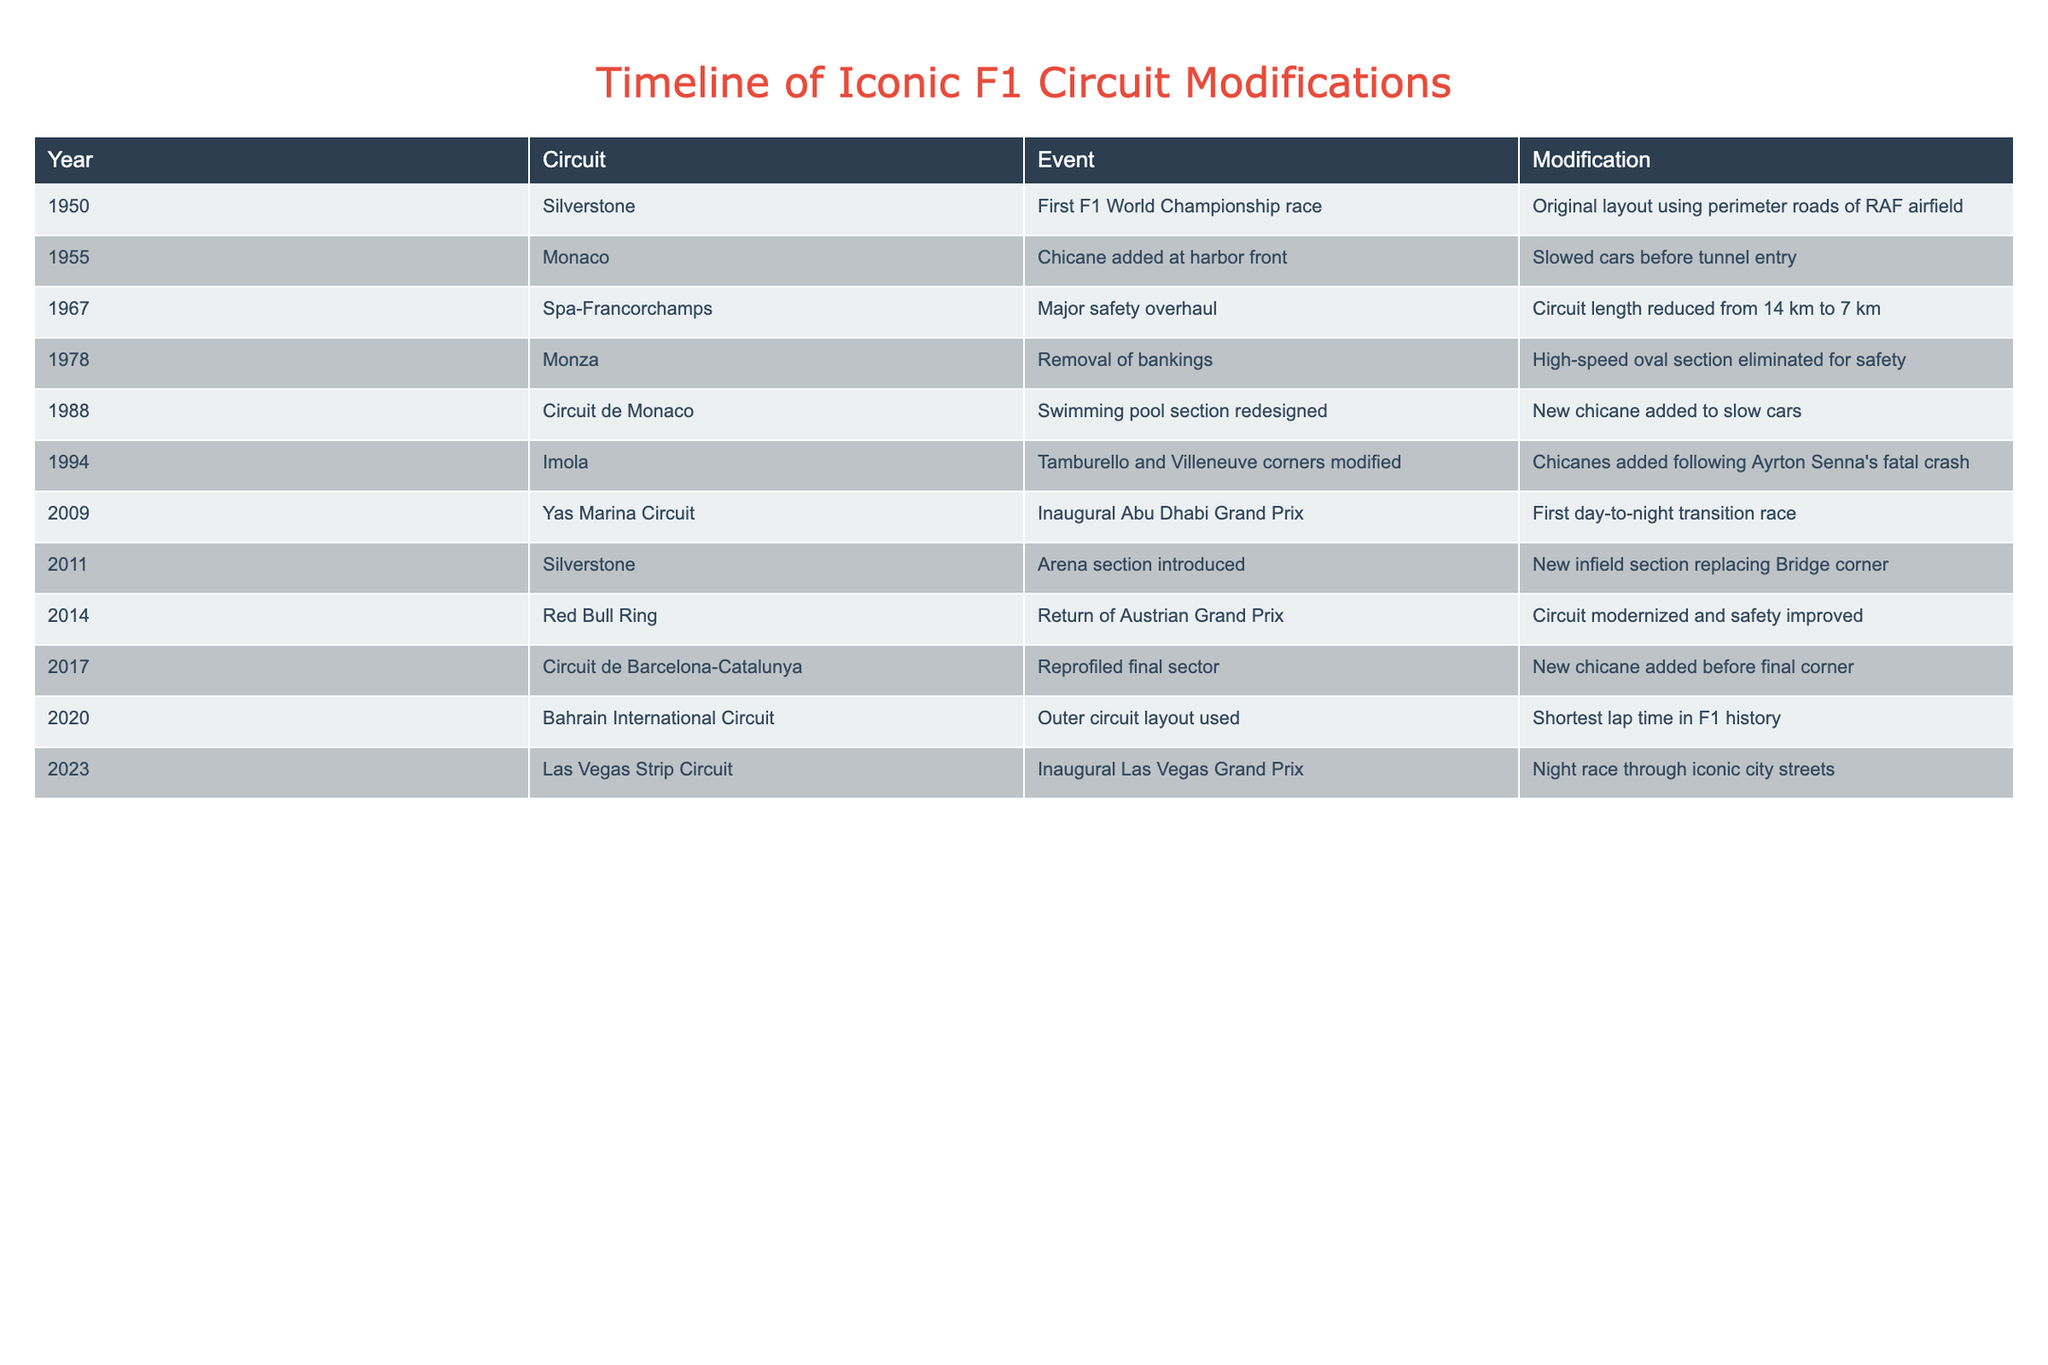What year was the first F1 World Championship race held? The table specifies that the first F1 World Championship race took place in the year 1950, which is provided in the "Year" column next to "Silverstone" in the "Circuit" column
Answer: 1950 Which circuit underwent a major safety overhaul in 1967? The table indicates that Spa-Francorchamps is the circuit that had a major safety overhaul in 1967, as seen in the "Circuit" column and confirmed by the "Event" column
Answer: Spa-Francorchamps Was the banked section of Monza removed for safety reasons? The table states that in 1978, the high-speed oval section of Monza was eliminated for safety, indicating that this modification was indeed for safety reasons
Answer: Yes In what year was the circuit layout modified that introduced the outer circuit layout in Bahrain? The table shows that the outer circuit layout in Bahrain was used in 2020. This information comes from the "Year" column next to "Bahrain International Circuit" in the "Circuit" column
Answer: 2020 How many circuits had modifications related to safety? By reviewing the table, there are three incidents related to safety: Spa-Francorchamps in 1967, Monza in 1978, and Imola in 1994. Thus, we count these three entries
Answer: 3 Which event involved the first day-to-night transition race, and in what year did it occur? The table records that the inaugural Abu Dhabi Grand Prix took place in 2009 and marks the first day-to-night transition race, as detailed in the "Event" column
Answer: Abu Dhabi Grand Prix, 2009 Was there a modification to the swimming pool section of the Circuit de Monaco in 1988? According to the table, it states that there was a redesign of the swimming pool section of the Circuit de Monaco in 1988, confirming that a modification indeed occurred
Answer: Yes What modification was made to the Circuit de Barcelona-Catalunya in 2017? The table indicates that in 2017, the final sector of Circuit de Barcelona-Catalunya was reprofiled, specifically mentioning the addition of a new chicane before the final corner
Answer: A new chicane before the final corner 